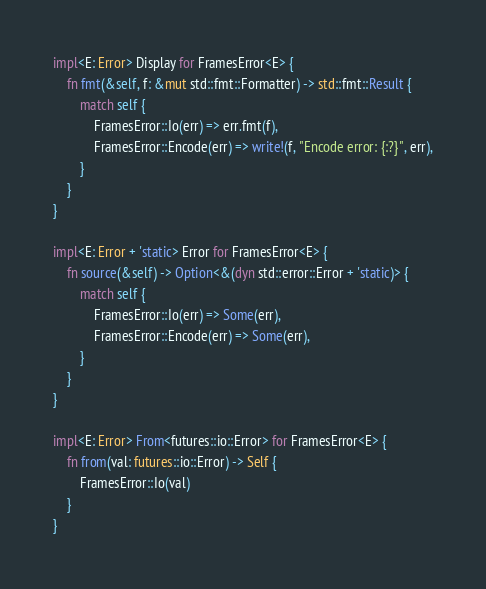Convert code to text. <code><loc_0><loc_0><loc_500><loc_500><_Rust_>impl<E: Error> Display for FramesError<E> {
    fn fmt(&self, f: &mut std::fmt::Formatter) -> std::fmt::Result {
        match self {
            FramesError::Io(err) => err.fmt(f),
            FramesError::Encode(err) => write!(f, "Encode error: {:?}", err),
        }
    }
}

impl<E: Error + 'static> Error for FramesError<E> {
    fn source(&self) -> Option<&(dyn std::error::Error + 'static)> {
        match self {
            FramesError::Io(err) => Some(err),
            FramesError::Encode(err) => Some(err),
        }
    }
}

impl<E: Error> From<futures::io::Error> for FramesError<E> {
    fn from(val: futures::io::Error) -> Self {
        FramesError::Io(val)
    }
}</code> 